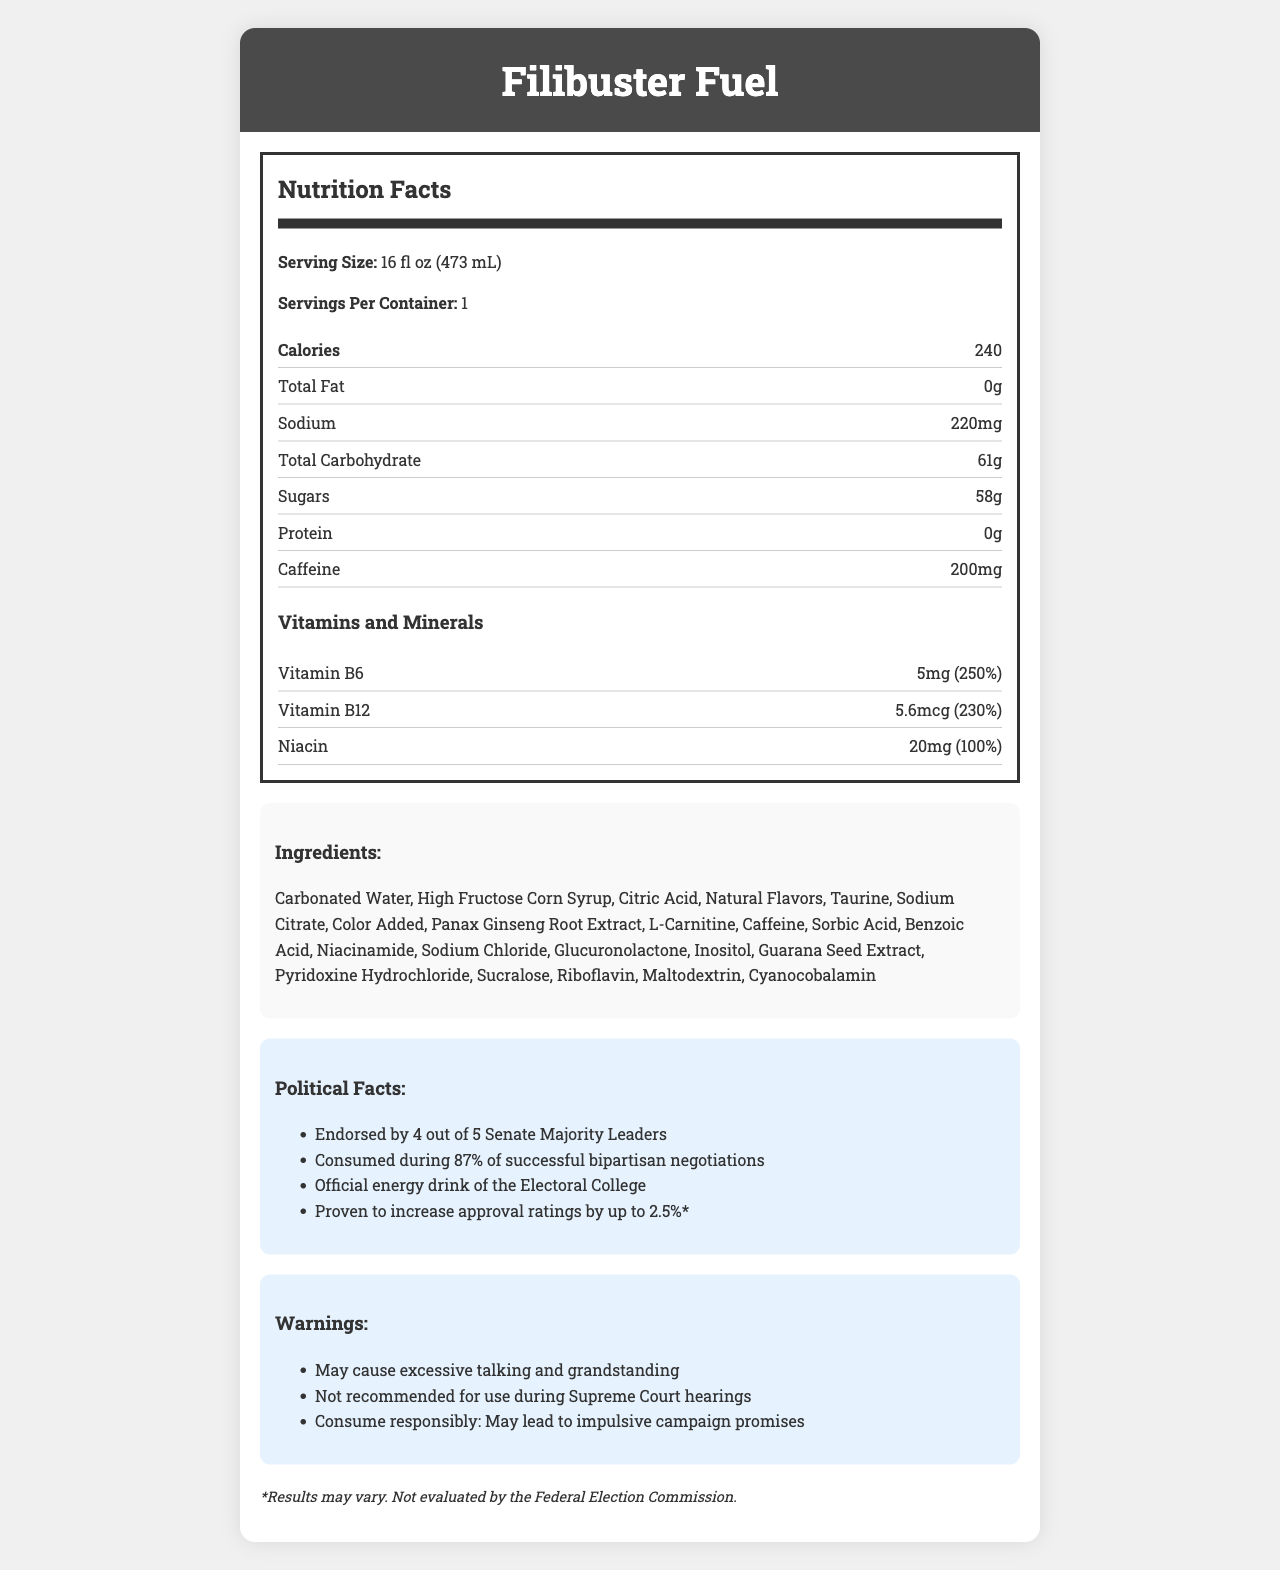what is the serving size of Filibuster Fuel? The serving size is clearly stated at the beginning of the Nutrition Facts section as "16 fl oz (473 mL)".
Answer: 16 fl oz (473 mL) how much sugar is in one serving of Filibuster Fuel? The amount of sugar is listed under the "Total Carbohydrate" section within the Nutrition Facts as "Sugars: 58g".
Answer: 58g how many calories are in one serving? The calorie content is listed at the top of the Nutrition Facts section as "Calories: 240".
Answer: 240 what are the total carbohydrates in one serving? The total carbohydrate amount is listed under the "Total Carbohydrate" section within the Nutrition Facts as "Total Carbohydrate: 61g".
Answer: 61g how much caffeine does Filibuster Fuel contain? The caffeine content is listed near the bottom of the Nutrition Facts section as "Caffeine: 200mg".
Answer: 200mg filibuster fuel contains which vitamins and minerals at 250% of their daily value? A. Vitamin B6 B. Vitamin B12 C. Niacin D. Vitamin C The Nutrition Facts lists "Vitamin B6" with a daily value of "250%".
Answer: A. Vitamin B6 what ingredient is listed first on the Ingredients list? The first ingredient listed in the Ingredients section is "Carbonated Water".
Answer: Carbonated Water how many Senate Majority Leaders have endorsed Filibuster Fuel? It's stated in the Political Facts section that "Filibuster Fuel" is "Endorsed by 4 out of 5 Senate Majority Leaders".
Answer: 4 out of 5 which warning is NOT associated with Filibuster Fuel consumption? A. May cause excessive talking and grandstanding B. Not recommended for use during Supreme Court hearings C. May contain traces of nuts There is no mention of "May contain traces of nuts" in the Warnings section.
Answer: C. May contain traces of nuts can Filibuster Fuel consumption lead to impulsive campaign promises? One of the warnings states: "Consume responsibly: May lead to impulsive campaign promises".
Answer: Yes which fact is true about Filibuster Fuel's role in bipartisan negotiations? The Political Facts section states: "Consumed during 87% of successful bipartisan negotiations".
Answer: It is consumed during 87% of successful bipartisan negotiations describe the main idea of the document The document offers detailed nutrition facts, lists ingredients, highlights political endorsements, notes potential effects on behavior, and outlines vitamins and minerals found in the energy drink.
Answer: The document provides comprehensive information about Filibuster Fuel, including its nutritional value, ingredients, endorsements and political influence, warnings, and vitamin/mineral content. what results are reported to be variable and not evaluated by a federal agency? The footnote at the bottom of the document specifies these details.
Answer: The claim that Filibuster Fuel "Proven to increase approval ratings by up to 2.5%*" is noted with a footnote stating "*Results may vary. Not evaluated by the Federal Election Commission." what is the relationship between consumption of Filibuster Fuel and Supreme Court hearings? The Warnings section clearly advises that Filibuster Fuel is "Not recommended for use during Supreme Court hearings".
Answer: Not recommended for use during Supreme Court hearings what is the purpose of the document? The document provides various details about Filibuster Fuel but does not explicitly state its purpose.
Answer: Cannot be determined 